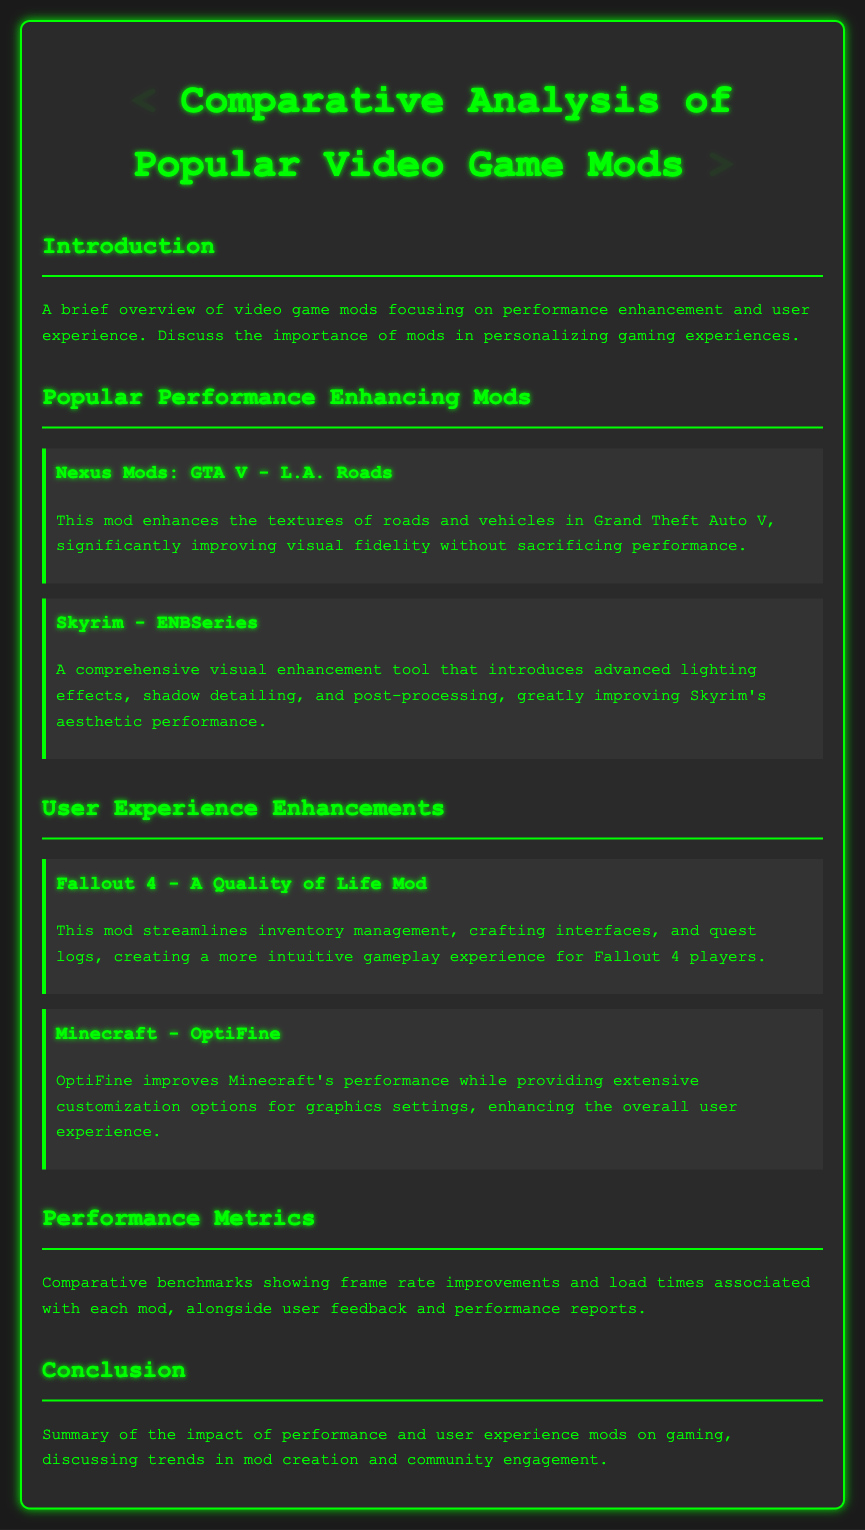What is the title of the document? The title of the document is stated prominently at the top, summarizing the main theme, which is a comparative analysis of video game mods.
Answer: Comparative Analysis of Popular Video Game Mods Which mod enhances textures in GTA V? The mod specifically mentioned for enhancing textures in Grand Theft Auto V is identified under the popular performance-enhancing mods section.
Answer: L.A. Roads What type of improvements does the ENBSeries mod introduce in Skyrim? The ENBSeries mod is noted for enhancing aesthetic performance through various visual enhancements like lighting effects.
Answer: Visual enhancement What does the Quality of Life Mod improve in Fallout 4? The document highlights that this mod enhances user experience by streamlining specific aspects of gameplay, particularly the organization of game elements.
Answer: Inventory management Which mod provides customization options for Minecraft's graphics? The name of the mod that allows extensive customization of graphics settings in Minecraft is mentioned in the user experience enhancements section.
Answer: OptiFine What is the focus of the introduction section? The introduction provides a brief overview that sets the context for the document, emphasizing the significance of mods.
Answer: Importance of mods What are performance metrics used for in the document? The performance metrics are designated for analyzing the improvements in frame rates and load times related to the discussed mods.
Answer: Frame rate improvements What is the main subject of the conclusion? The conclusion summarizes the broader implications of the discussed mods and trends within the modding community.
Answer: Impact of performance and user experience mods 